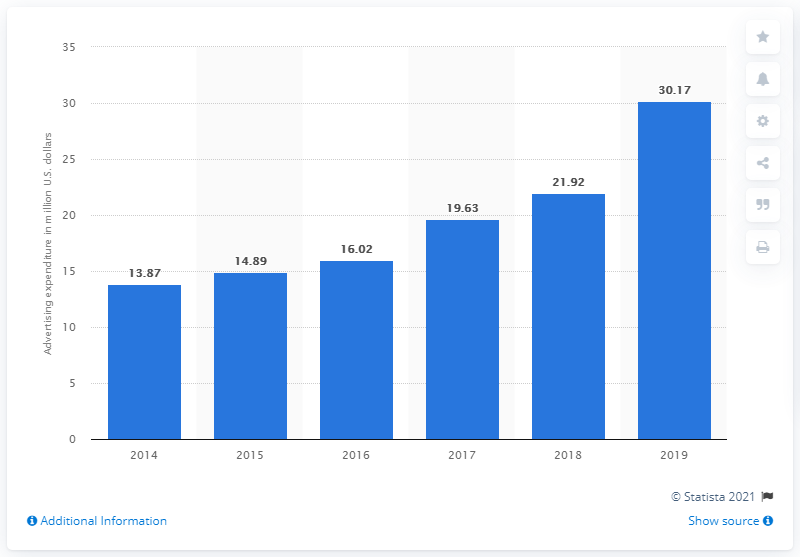Point out several critical features in this image. Steve Madden's advertising expenditure in 2019 was 30.17 million. 